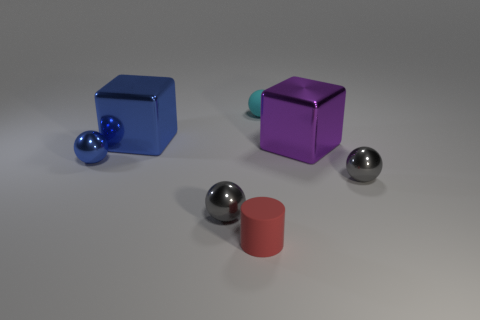If I were to arrange these objects by size, from smallest to largest, what would that look like? Starting with the smallest, you would have the three spheres, with the gray ones being identically sized and the smallest, followed by the blue sphere which is slightly larger. The next in size would be the red cylinder, followed by the blue cube and lastly, the largest object, the purple cube. 